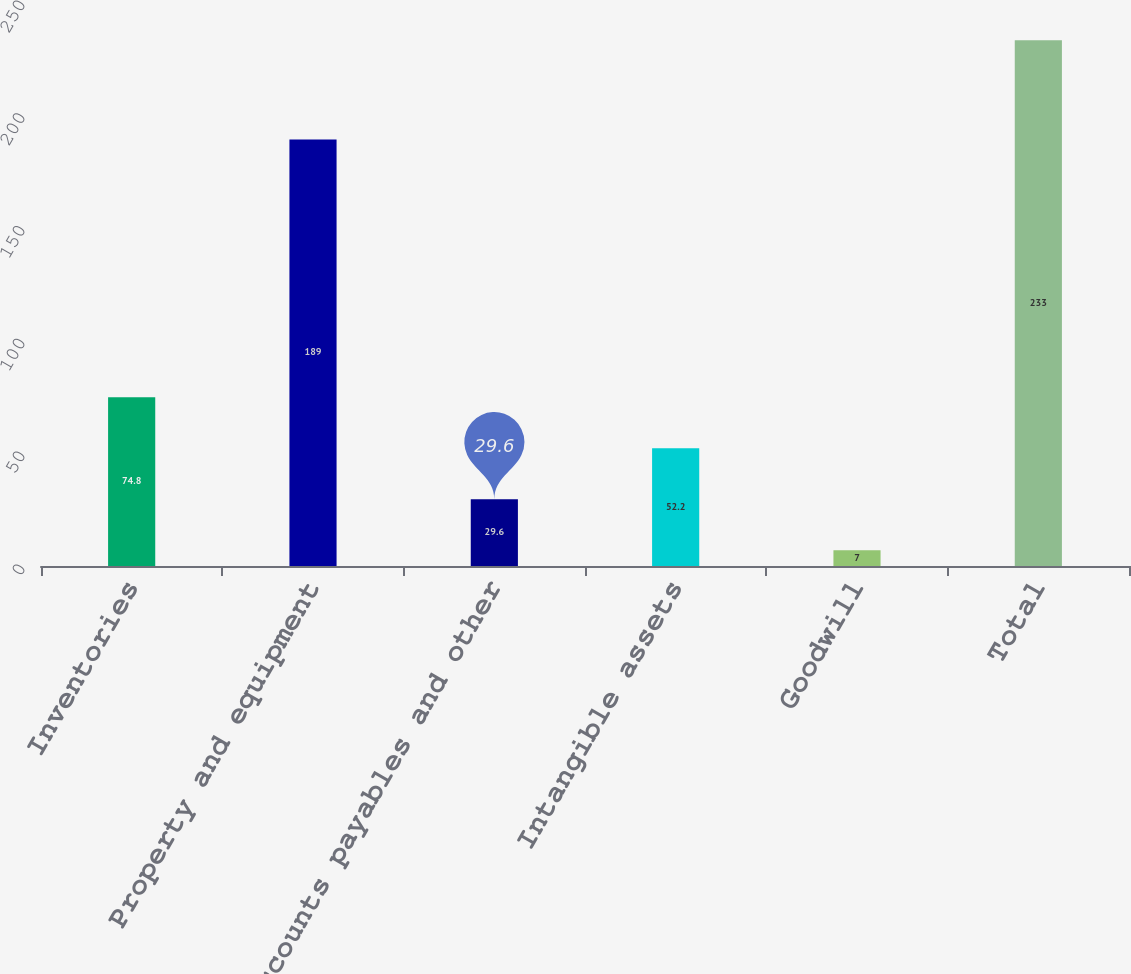Convert chart to OTSL. <chart><loc_0><loc_0><loc_500><loc_500><bar_chart><fcel>Inventories<fcel>Property and equipment<fcel>Accounts payables and other<fcel>Intangible assets<fcel>Goodwill<fcel>Total<nl><fcel>74.8<fcel>189<fcel>29.6<fcel>52.2<fcel>7<fcel>233<nl></chart> 